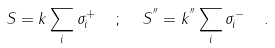Convert formula to latex. <formula><loc_0><loc_0><loc_500><loc_500>S = k \sum _ { i } \sigma ^ { + } _ { i } \ \ ; \ \ S ^ { ^ { \prime \prime } } = k ^ { ^ { \prime \prime } } \sum _ { i } \sigma ^ { - } _ { i } \ \ .</formula> 